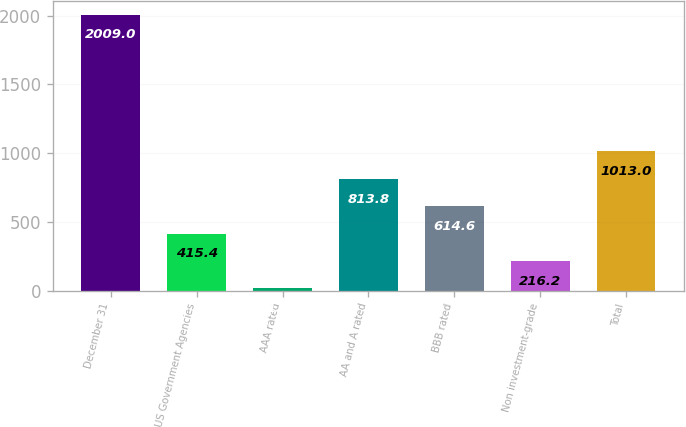Convert chart. <chart><loc_0><loc_0><loc_500><loc_500><bar_chart><fcel>December 31<fcel>US Government Agencies<fcel>AAA rated<fcel>AA and A rated<fcel>BBB rated<fcel>Non investment-grade<fcel>Total<nl><fcel>2009<fcel>415.4<fcel>17<fcel>813.8<fcel>614.6<fcel>216.2<fcel>1013<nl></chart> 